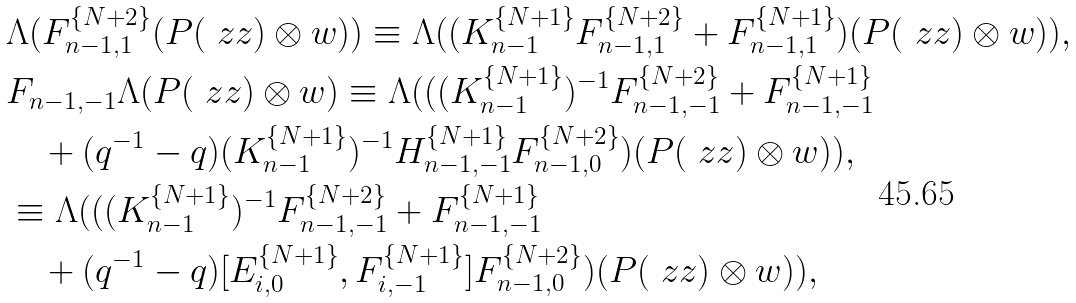Convert formula to latex. <formula><loc_0><loc_0><loc_500><loc_500>& \Lambda ( F _ { n - 1 , 1 } ^ { \{ N + 2 \} } ( P ( \ z z ) \otimes w ) ) \equiv \Lambda ( ( K _ { n - 1 } ^ { \{ N + 1 \} } F _ { n - 1 , 1 } ^ { \{ N + 2 \} } + F _ { n - 1 , 1 } ^ { \{ N + 1 \} } ) ( P ( \ z z ) \otimes w ) ) , \\ & F _ { n - 1 , - 1 } \Lambda ( P ( \ z z ) \otimes w ) \equiv \Lambda ( ( ( K _ { n - 1 } ^ { \{ N + 1 \} } ) ^ { - 1 } F _ { n - 1 , - 1 } ^ { \{ N + 2 \} } + F _ { n - 1 , - 1 } ^ { \{ N + 1 \} } \\ & \quad + ( q ^ { - 1 } - q ) ( K _ { n - 1 } ^ { \{ N + 1 \} } ) ^ { - 1 } H _ { n - 1 , - 1 } ^ { \{ N + 1 \} } F _ { n - 1 , 0 } ^ { \{ N + 2 \} } ) ( P ( \ z z ) \otimes w ) ) , \\ & \equiv \Lambda ( ( ( K _ { n - 1 } ^ { \{ N + 1 \} } ) ^ { - 1 } F _ { n - 1 , - 1 } ^ { \{ N + 2 \} } + F _ { n - 1 , - 1 } ^ { \{ N + 1 \} } \\ & \quad + ( q ^ { - 1 } - q ) [ E _ { i , 0 } ^ { \{ N + 1 \} } , F _ { i , - 1 } ^ { \{ N + 1 \} } ] F _ { n - 1 , 0 } ^ { \{ N + 2 \} } ) ( P ( \ z z ) \otimes w ) ) ,</formula> 